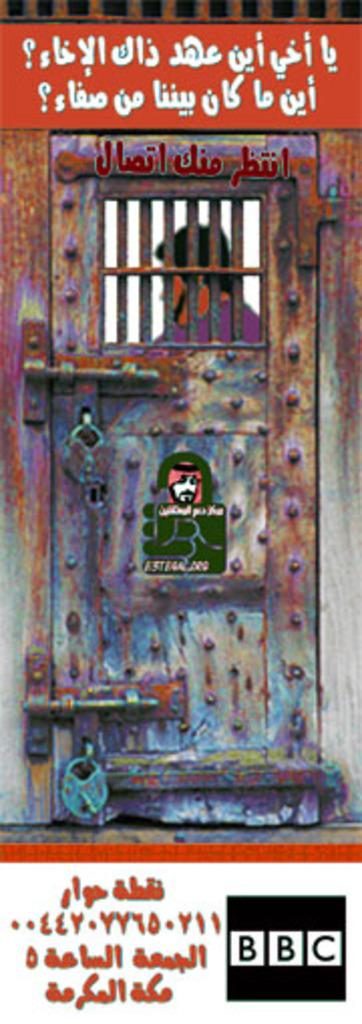<image>
Share a concise interpretation of the image provided. The BBC logo can be seen below a man behind bars. 